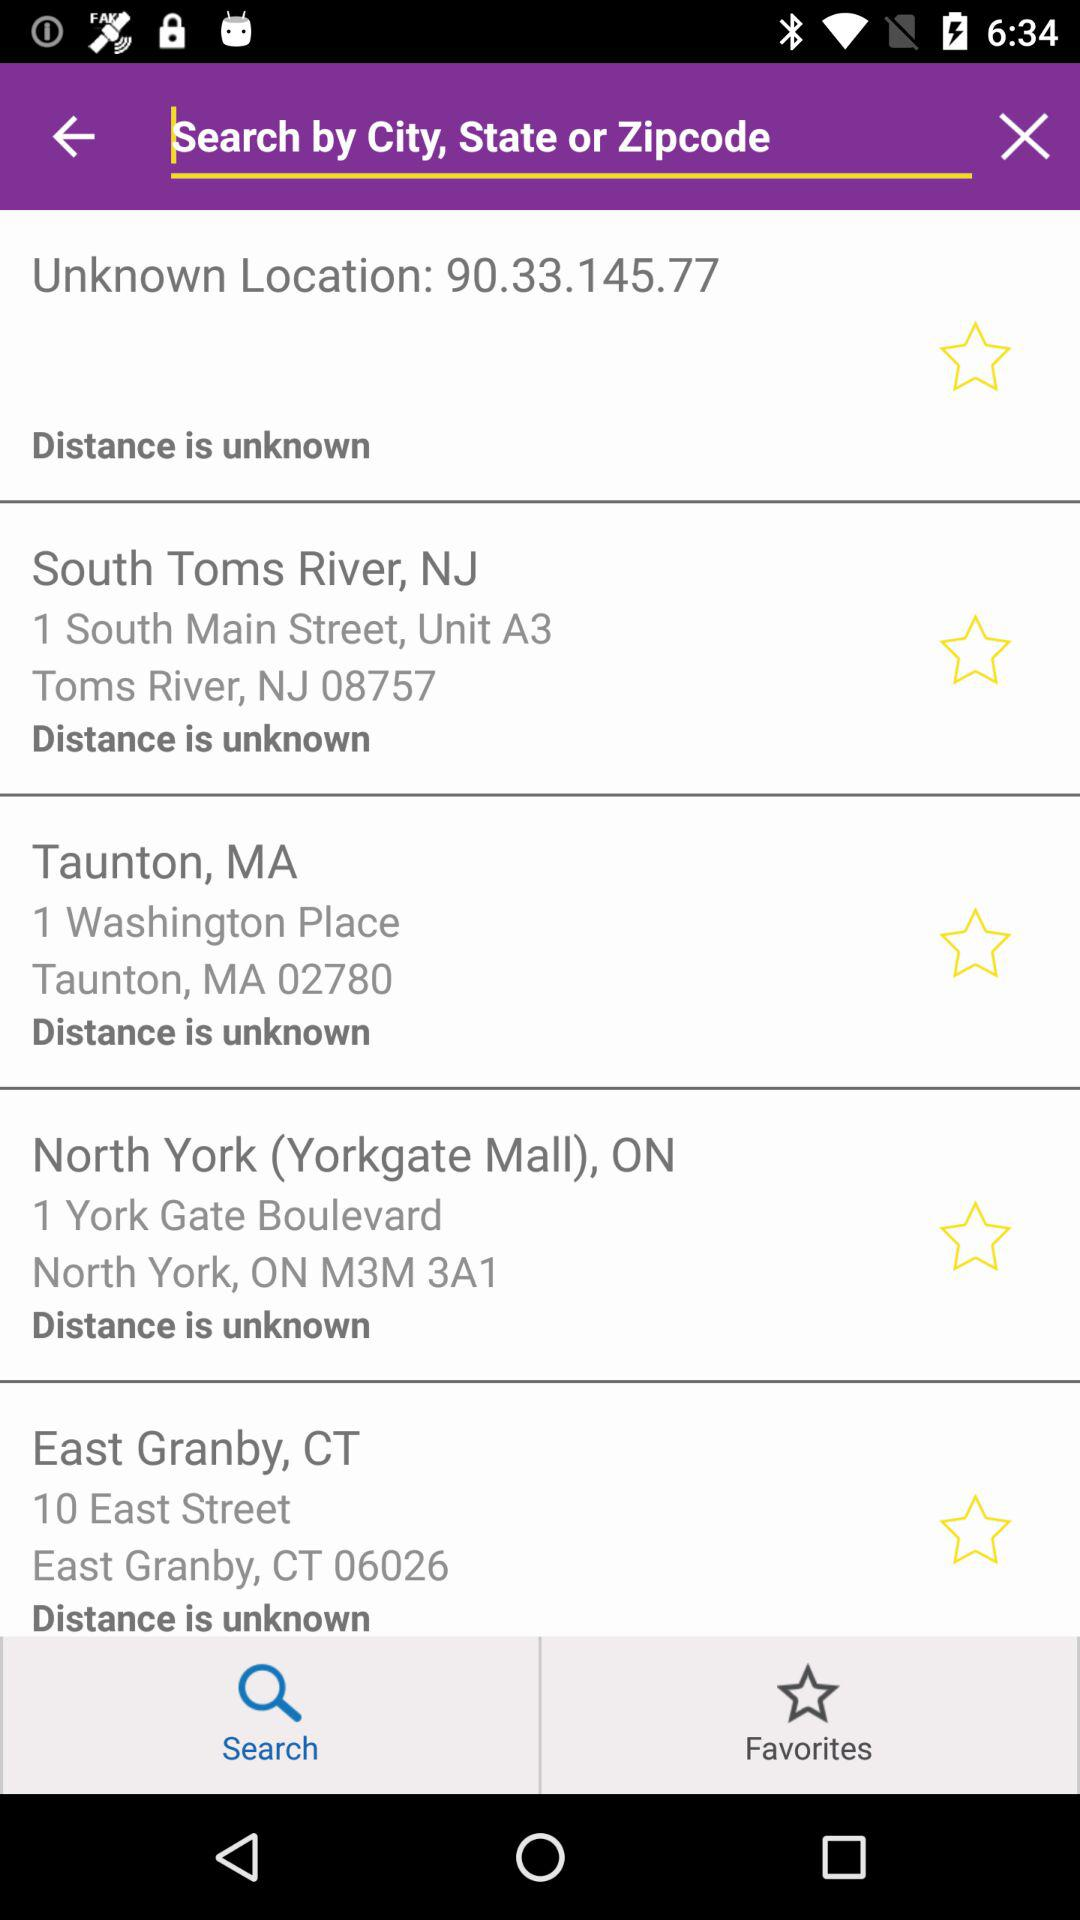Which locations are saved in "Favorites"?
When the provided information is insufficient, respond with <no answer>. <no answer> 